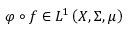<formula> <loc_0><loc_0><loc_500><loc_500>\varphi \circ f \in L ^ { 1 } \left ( X , \Sigma , \mu \right )</formula> 